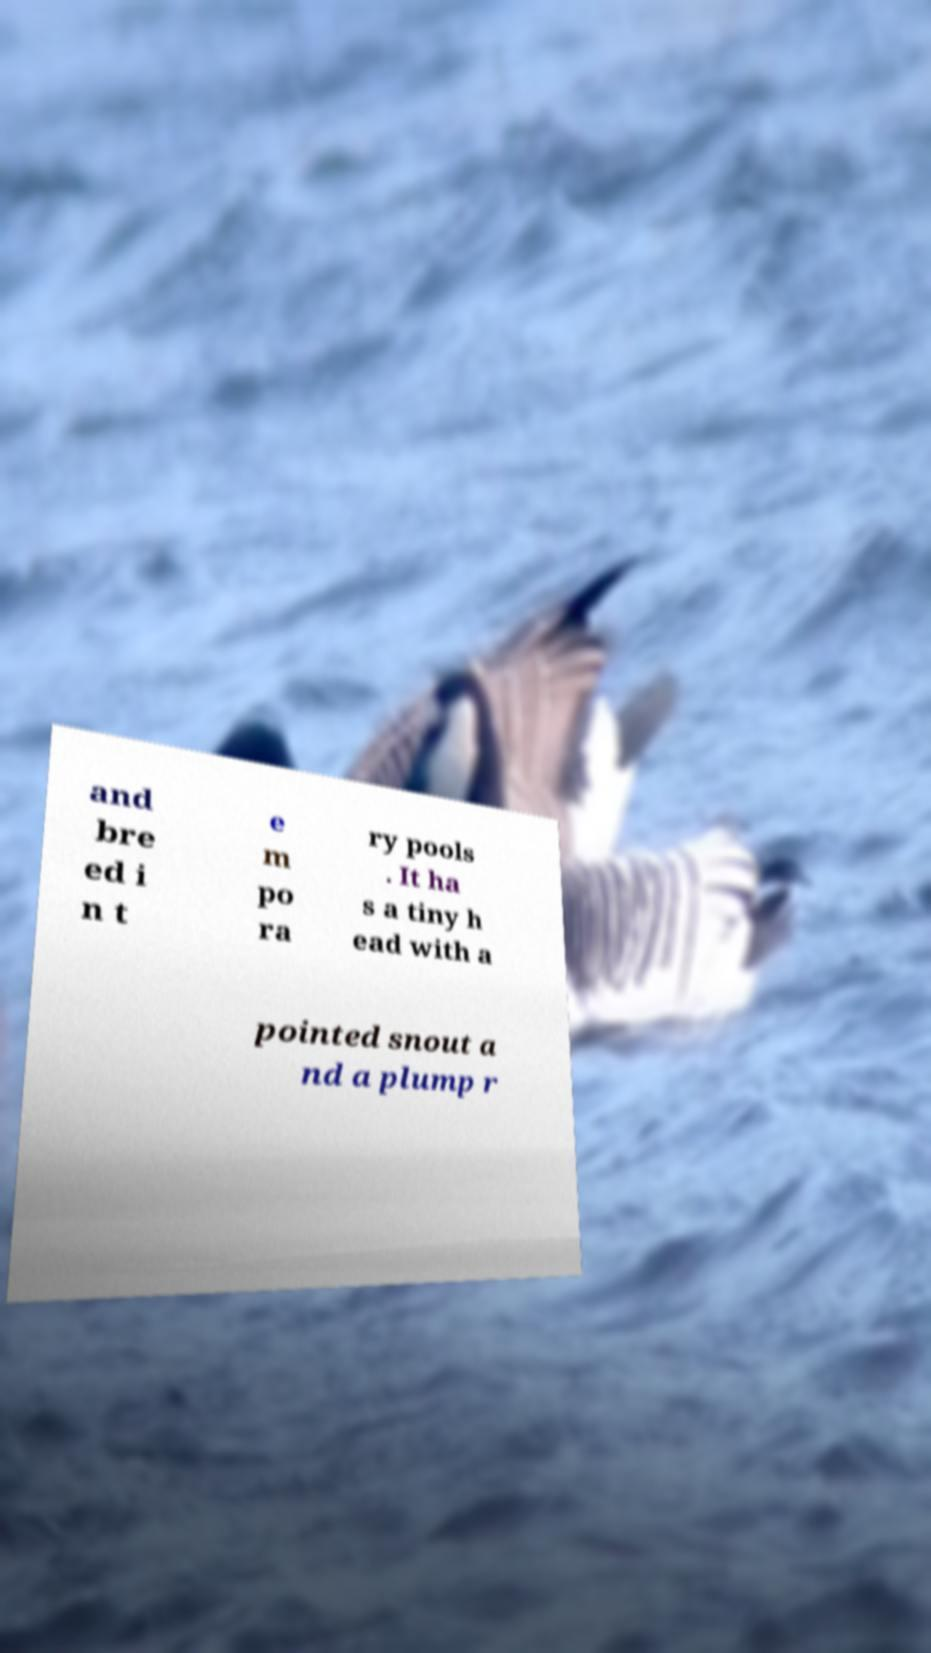Could you assist in decoding the text presented in this image and type it out clearly? and bre ed i n t e m po ra ry pools . It ha s a tiny h ead with a pointed snout a nd a plump r 